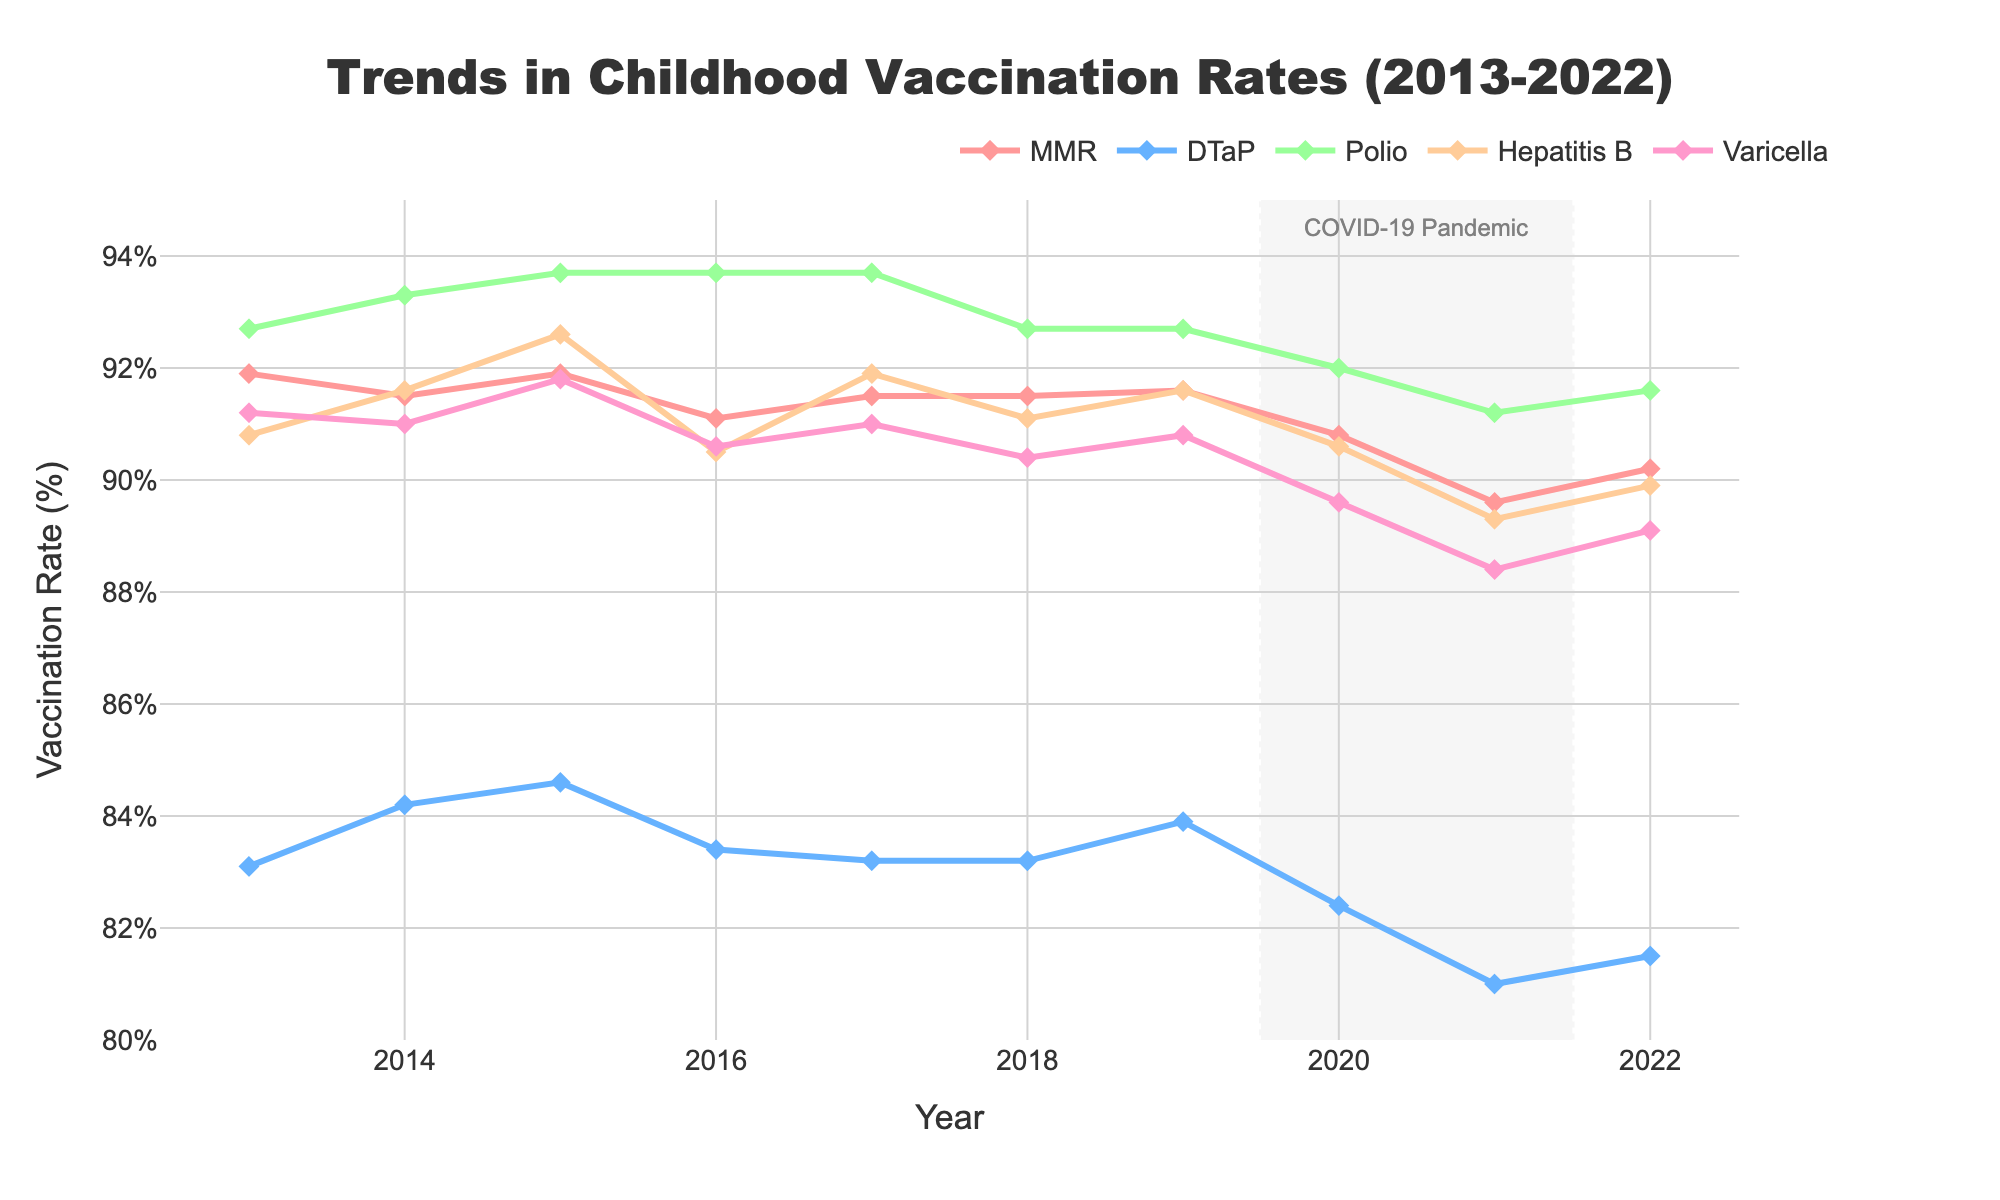What's the average DTaP vaccination rate from 2013 to 2022? To find the average, sum the DTaP rates from each year and then divide by the number of years. (83.1 + 84.2 + 84.6 + 83.4 + 83.2 + 83.2 + 83.9 + 82.4 + 81.0 + 81.5) / 10 = 830.5 / 10 = 83.05
Answer: 83.05% Which vaccine type saw the highest vaccination rate in 2022? Review the data points for 2022 and identify the highest rate among all vaccine types listed. MMR has 90.2%, DTaP has 81.5%, Polio has 91.6%, Hepatitis B has 89.9%, and Varicella has 89.1%. The highest rate is for Polio.
Answer: Polio Was there a drop in vaccination rates for any vaccine between 2019 and 2021? Compare the vaccination rates from 2019 to 2021 for each vaccine type. MMR drops from 91.6% to 89.6%, DTaP drops from 83.9% to 81.0%, Polio drops from 92.7% to 91.2%, Hepatitis B drops from 91.6% to 89.3%, and Varicella drops from 90.8% to 88.4%. All vaccine types experienced a drop during this period.
Answer: Yes Which vaccine's rate changed the least during the COVID-19 pandemic period (2020-2021)? Calculate the absolute change for each vaccine type from 2020 to 2021. Changes are: MMR (90.8 to 89.6) = 1.2, DTaP (82.4 to 81.0) = 1.4, Polio (92.0 to 91.2) = 0.8, Hepatitis B (90.6 to 89.3) = 1.3, Varicella (89.6 to 88.4) = 1.2. The Polio vaccine had the smallest change.
Answer: Polio Which vaccine had the most consistent rates over the decade? Look at the fluctuation patterns for each vaccine type from 2013 to 2022. MMR and Polio exhibit the least fluctuation overall. Compare the range of values (highest value - lowest value) for each vaccine type. MMR ranges from 91.9 to 89.6 (range of 2.3), DTaP ranges from 84.6 to 81.0 (range of 3.6), Polio ranges from 93.7 to 91.2 (range of 2.5), Hepatitis B ranges from 92.6 to 89.3 (range of 3.3), and Varicella ranges from 91.8 to 88.4 (range of 3.4). MMR had the smallest range, implying the most consistency.
Answer: MMR What's the median vaccination rate for Hepatitis B in the past decade? To find the median, list the Hepatitis B rates in ascending order and find the middle value. The sorted values are: 89.3, 89.9, 90.5, 90.6, 90.6, 91.1, 91.6, 91.6, 91.9, 92.6. The median is the average of the 5th and 6th values: (90.6 + 90.6) / 2 = 90.6.
Answer: 90.6% 